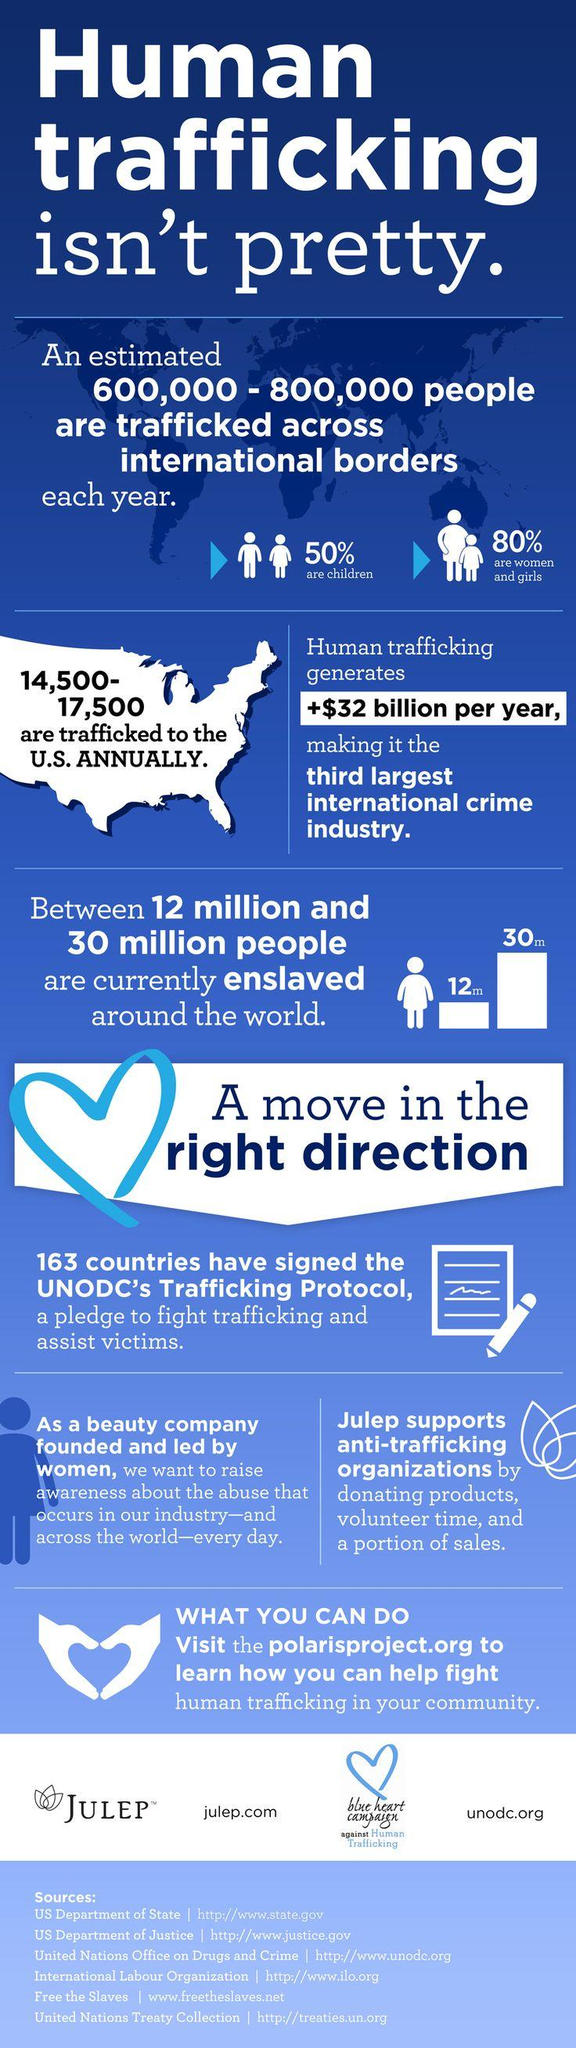Outline some significant characteristics in this image. What is the count of which 50% are children? The count refers to the population of 600,000 and 800,000 people. Of the 800,000 people in the sample, 80% are women and girls. The count of women and girls in this sample is 600,000 - 800,000. According to estimates, the annual revenue generated by human trafficking is approximately $32 billion. Human trafficking is the third largest international crime industry, according to experts. Julep is the beauty company that was mentioned. 